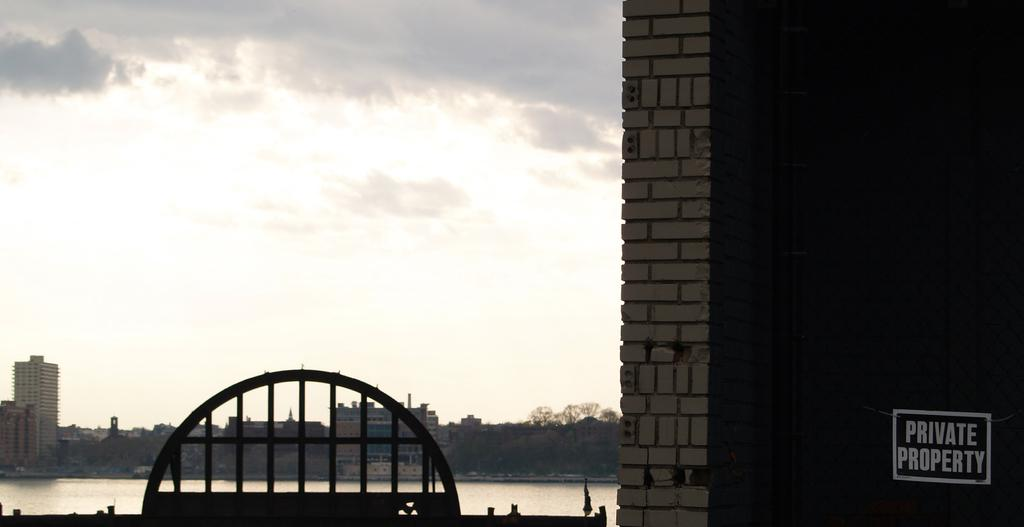Provide a one-sentence caption for the provided image. On teh fence to the left of the brick wall, hangs a sign that says Private Property. 